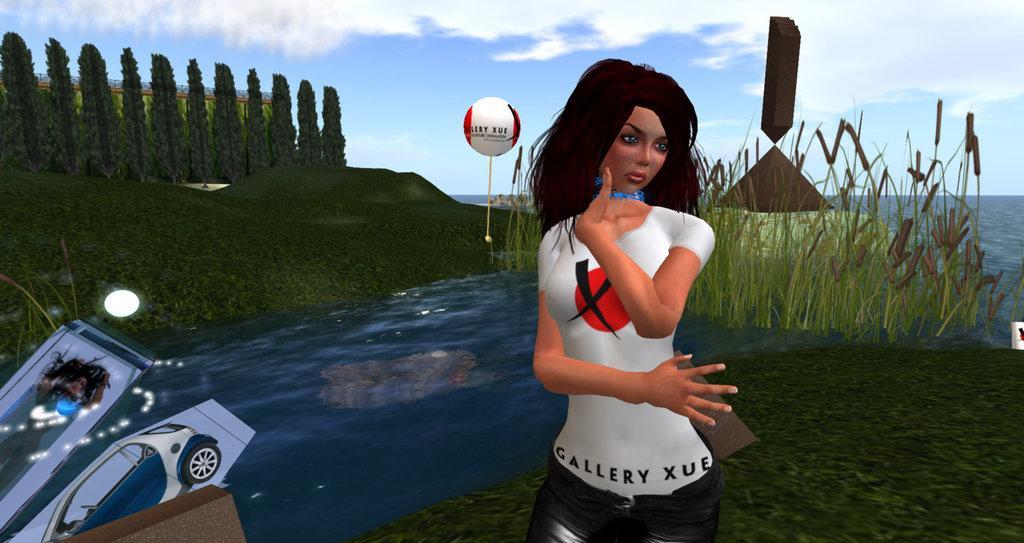Can you describe this image briefly? In this image I can see the animated picture and I can see the person standing and the person is wearing white and black color dress. In the background I can see few trees in green color and the sky is in blue and white color. 